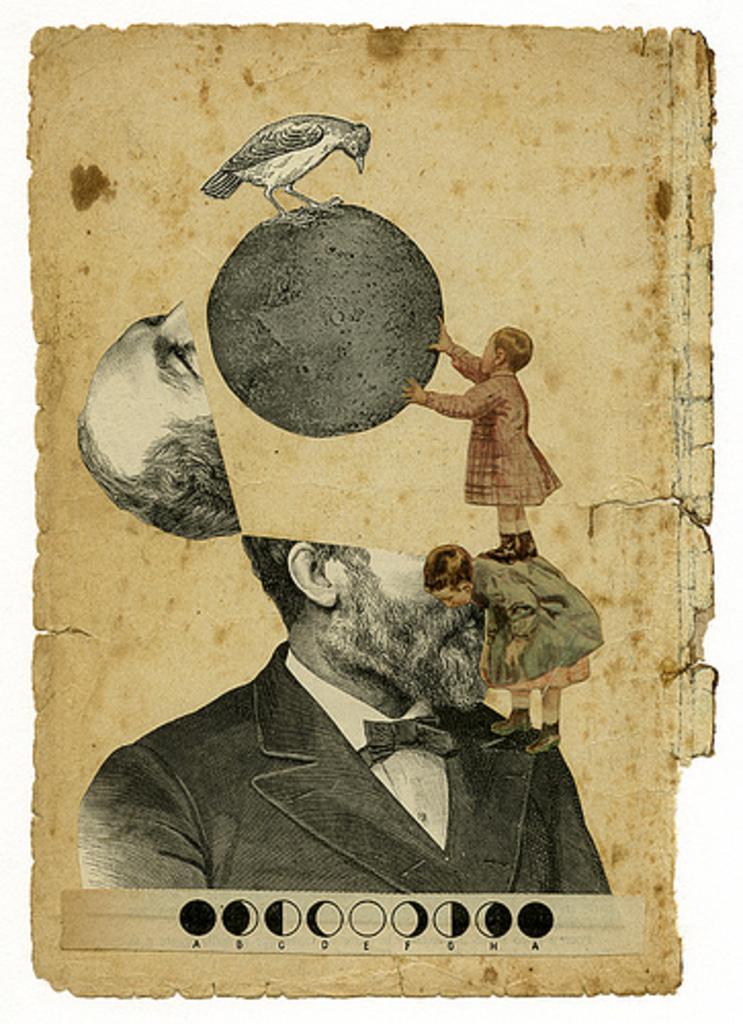In one or two sentences, can you explain what this image depicts? In this image I can see the poster. In the poster I can see the person with the blazer and I can see two children on the person. There is a bird on the black color object. To the left I can see the head of the person. 